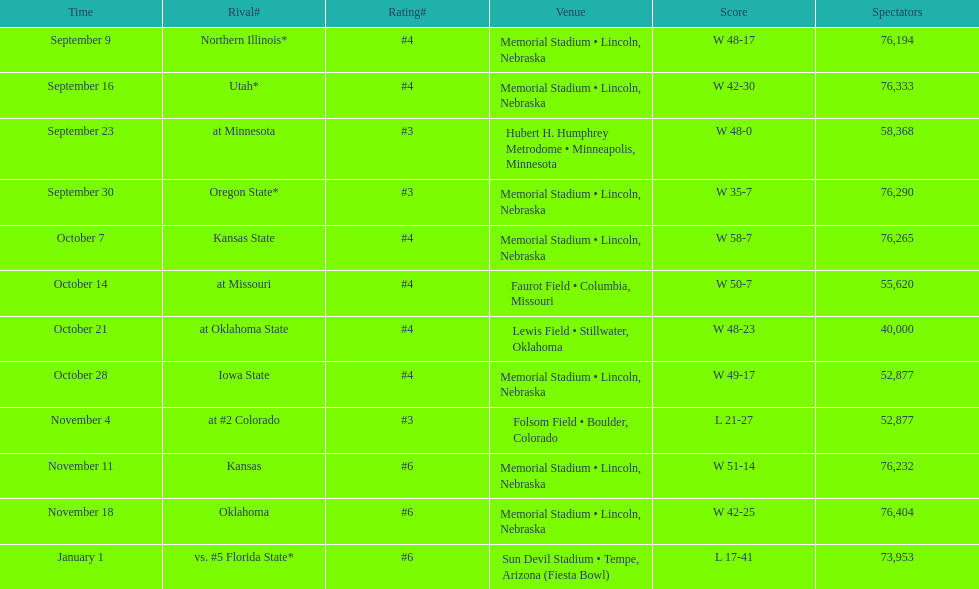When is the first game? September 9. 